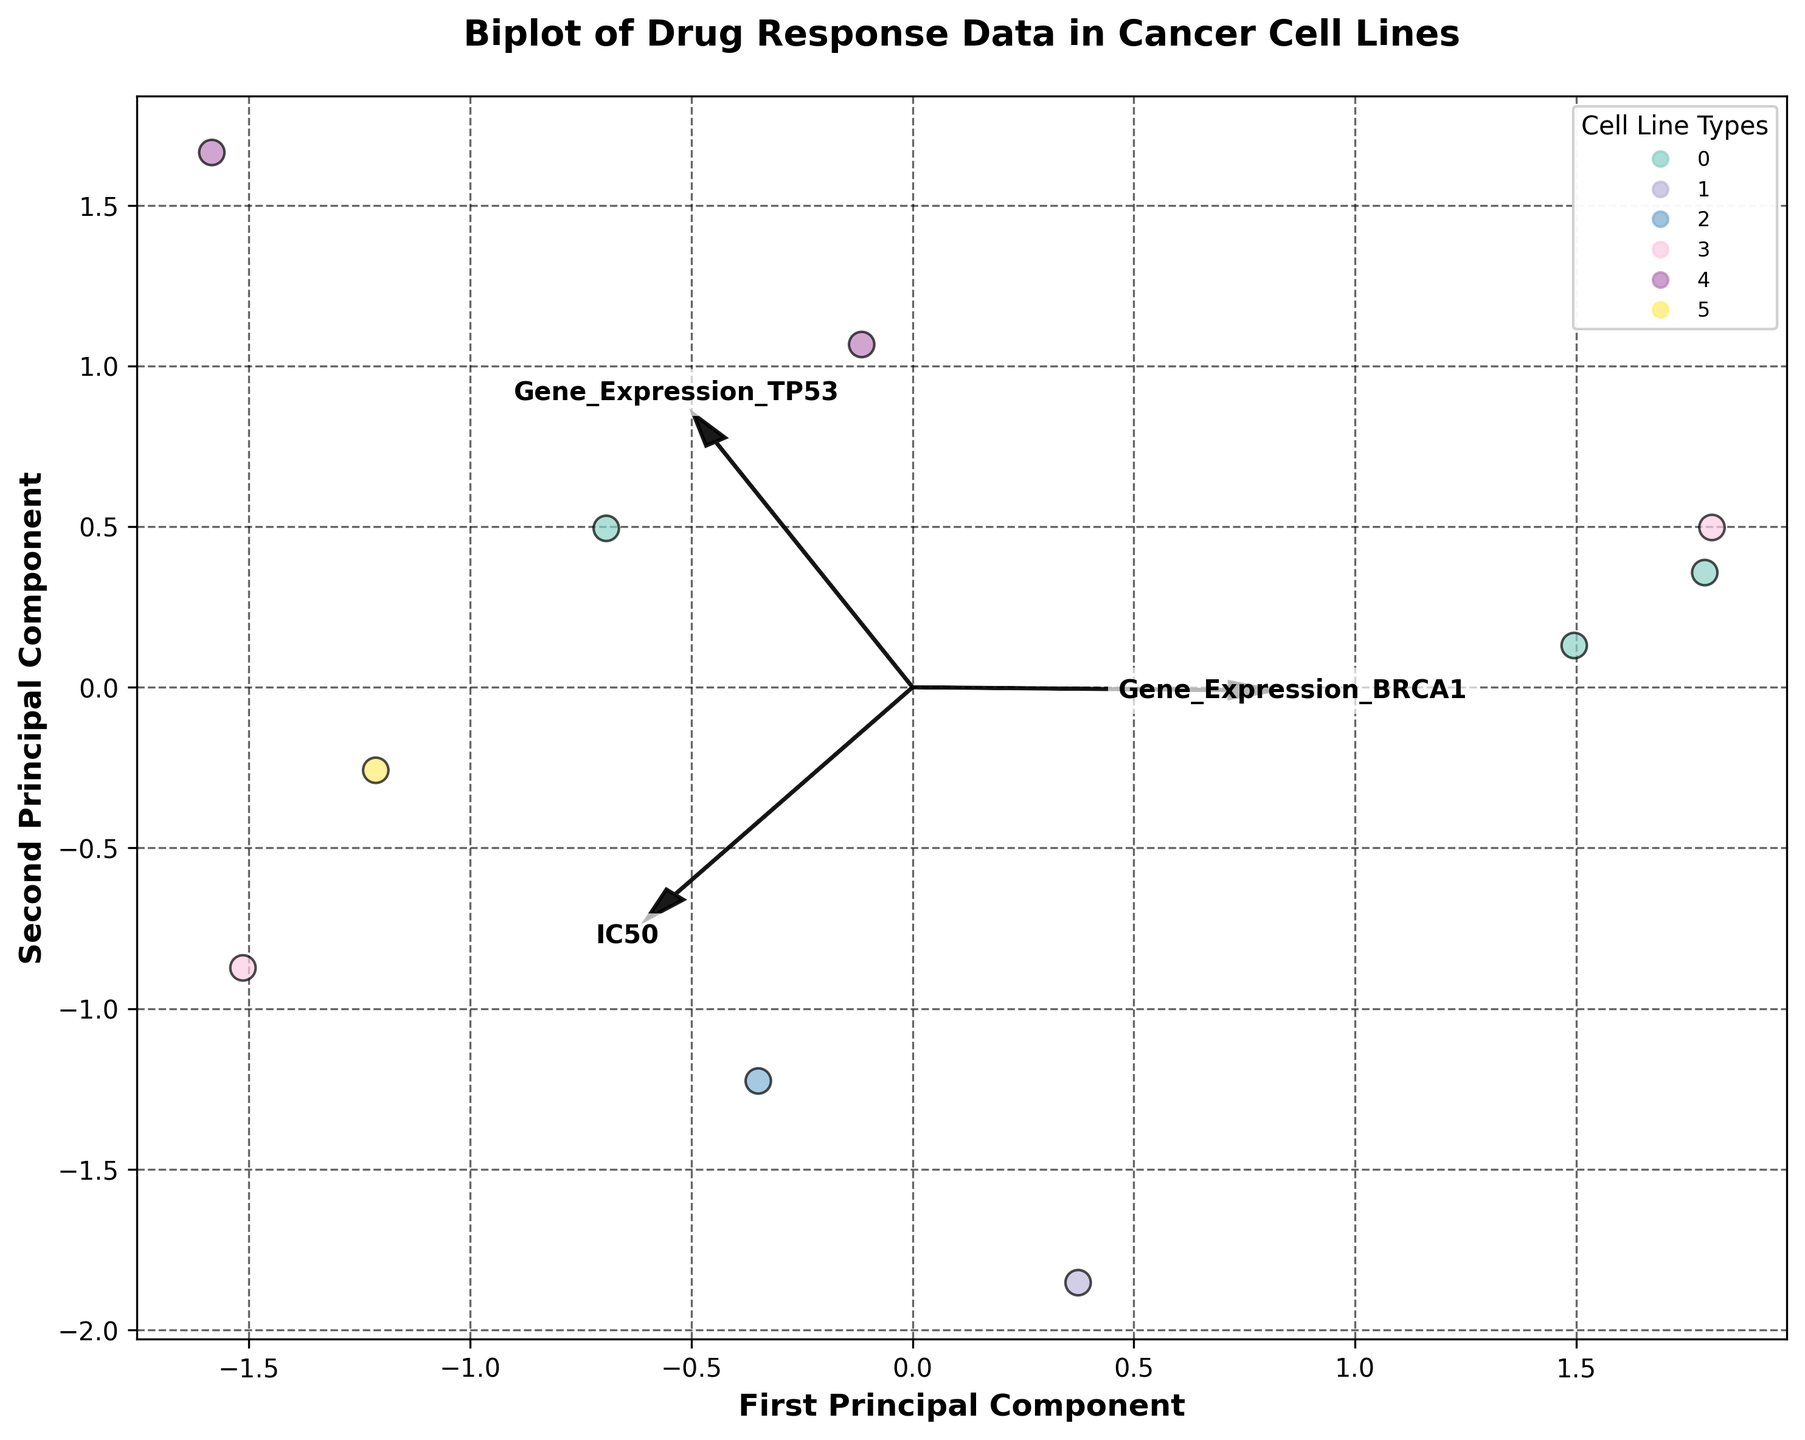What is the title of the figure? The title of the figure is prominently displayed at the top and it reads 'Biplot of Drug Response Data in Cancer Cell Lines'.
Answer: Biplot of Drug Response Data in Cancer Cell Lines How many cell line types are represented in the figure? By examining the legend, each unique color represents different cell line types. Counting these unique colors reveals the total number of cell line types.
Answer: 6 Which axis represents the first principal component? The label on the horizontal axis indicates that it is the 'First Principal Component'.
Answer: Horizontal axis Which feature vectors are plotted in the biplot? The arrows originating from the origin and the text labels attached to them indicate the feature vectors. They are labeled as 'IC50', 'Gene_Expression_BRCA1', and 'Gene_Expression_TP53'.
Answer: IC50, Gene_Expression_BRCA1, Gene_Expression_TP53 What does the length and direction of the arrows in the biplot represent? In a biplot, the length of the arrows represents the magnitude of the contribution of each feature to the principal components, while the direction shows the correlation between the features and the principal components.
Answer: Magnitude and correlation Which cell line type is most distant from the origin? By locating the data points in the figure, the cell line type that is farthest from the origin would represent the data point most distant from the origin.
Answer: Lung Which drug has the closest data point to the origin? Identifying the data points positioned closest to the origin in the biplot and cross-referencing with the drug names helps find the closest drug.
Answer: Tamoxifen Is Gene_Expression_BRCA1 more correlated with the First or the Second Principal Component? By observing the direction and alignment of the 'Gene_Expression_BRCA1' arrow relative to the principal component axes. We determine that it aligns more with one axis than the other.
Answer: First Principal Component Are the IC50 values positively or negatively associated with the First Principal Component? By examining the direction of the 'IC50' arrow relative to the First Principal Component axis, we can determine the sign of the association.
Answer: Positively associated 